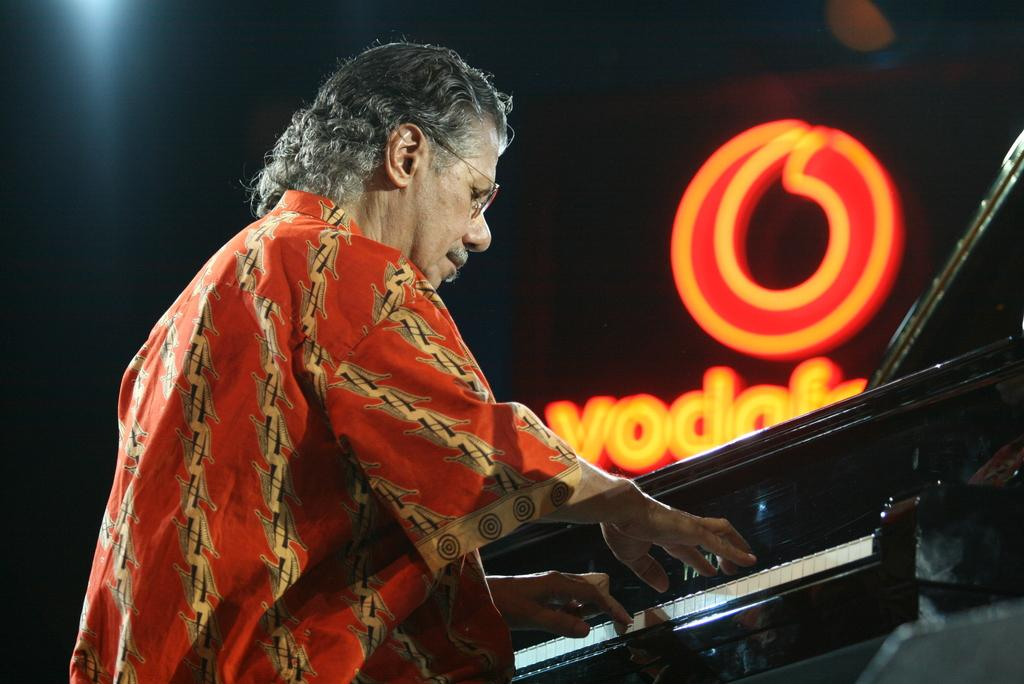Who is the person in the image? There is a man in the image. What is the man wearing? The man is wearing spectacles and a red dress. What is the man doing in the image? The man is playing a piano keyboard. Can you describe any other elements in the image? There is a logo in the image, which has red and orange colors. What type of teaching is the man conducting in the image? There is no indication in the image that the man is conducting any teaching. Can you see a train in the image? There is no train present in the image. 